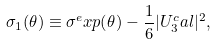<formula> <loc_0><loc_0><loc_500><loc_500>\sigma _ { 1 } ( \theta ) \equiv \sigma ^ { e } x p ( \theta ) - \frac { 1 } { 6 } | U _ { 3 } ^ { c } a l | ^ { 2 } ,</formula> 